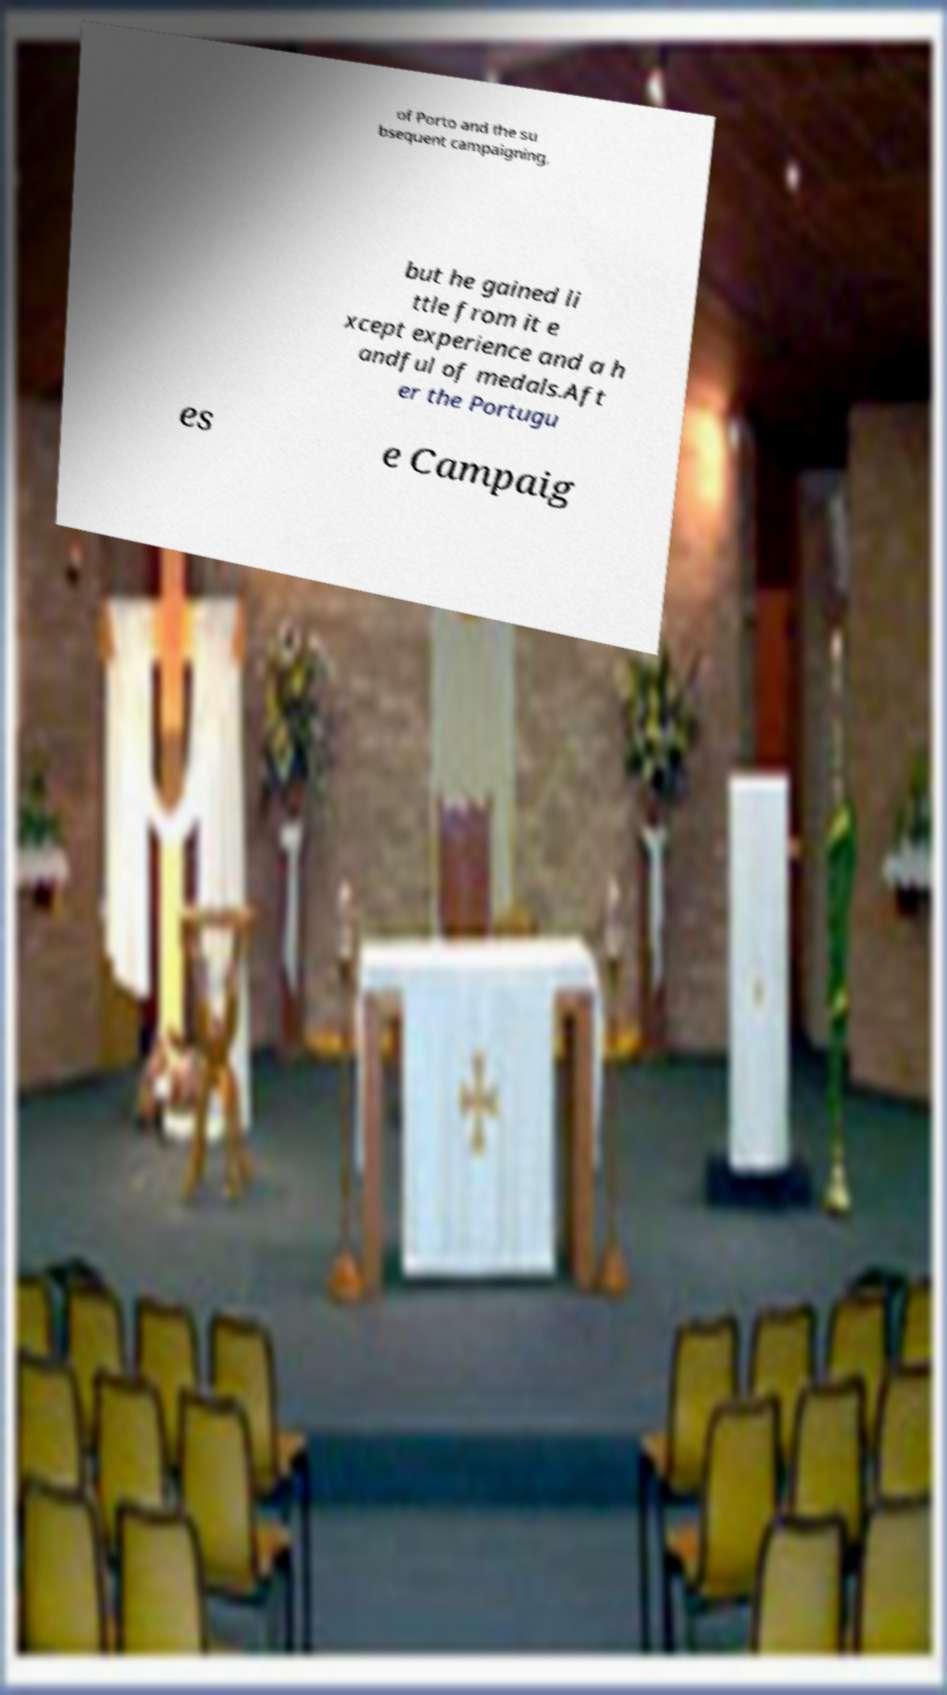Can you accurately transcribe the text from the provided image for me? of Porto and the su bsequent campaigning, but he gained li ttle from it e xcept experience and a h andful of medals.Aft er the Portugu es e Campaig 